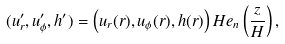<formula> <loc_0><loc_0><loc_500><loc_500>( u ^ { \prime } _ { r } , u ^ { \prime } _ { \phi } , h ^ { \prime } ) = \left ( u _ { r } ( r ) , u _ { \phi } ( r ) , h ( r ) \right ) H e _ { n } \left ( \frac { z } { H } \right ) ,</formula> 